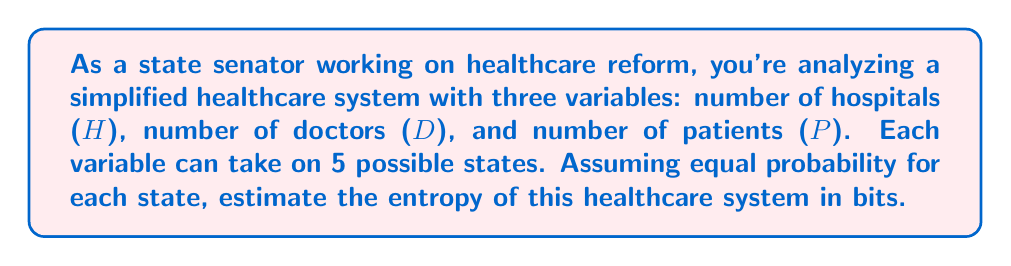Solve this math problem. To estimate the entropy of this healthcare system, we'll follow these steps:

1. Determine the number of possible microstates:
   Each variable (H, D, P) can take on 5 possible states.
   Total number of microstates = $5 \times 5 \times 5 = 125$

2. Calculate the probability of each microstate:
   Assuming equal probability, $p = \frac{1}{125}$

3. Use the entropy formula:
   $$S = -k_B \sum_{i} p_i \ln p_i$$
   Where $k_B$ is Boltzmann's constant (which we'll ignore for this calculation in bits)

4. Simplify the calculation:
   Since all probabilities are equal, we can simplify:
   $$S = -\sum_{i=1}^{125} \frac{1}{125} \ln \frac{1}{125}$$
   $$S = -125 \cdot \frac{1}{125} \ln \frac{1}{125}$$
   $$S = -\ln \frac{1}{125}$$
   $$S = \ln 125$$

5. Convert to bits:
   To convert from nats to bits, divide by $\ln(2)$:
   $$S_{bits} = \frac{\ln 125}{\ln 2}$$

6. Calculate the final result:
   $$S_{bits} = \frac{\ln 125}{\ln 2} \approx 6.97 \text{ bits}$$
Answer: $6.97 \text{ bits}$ 